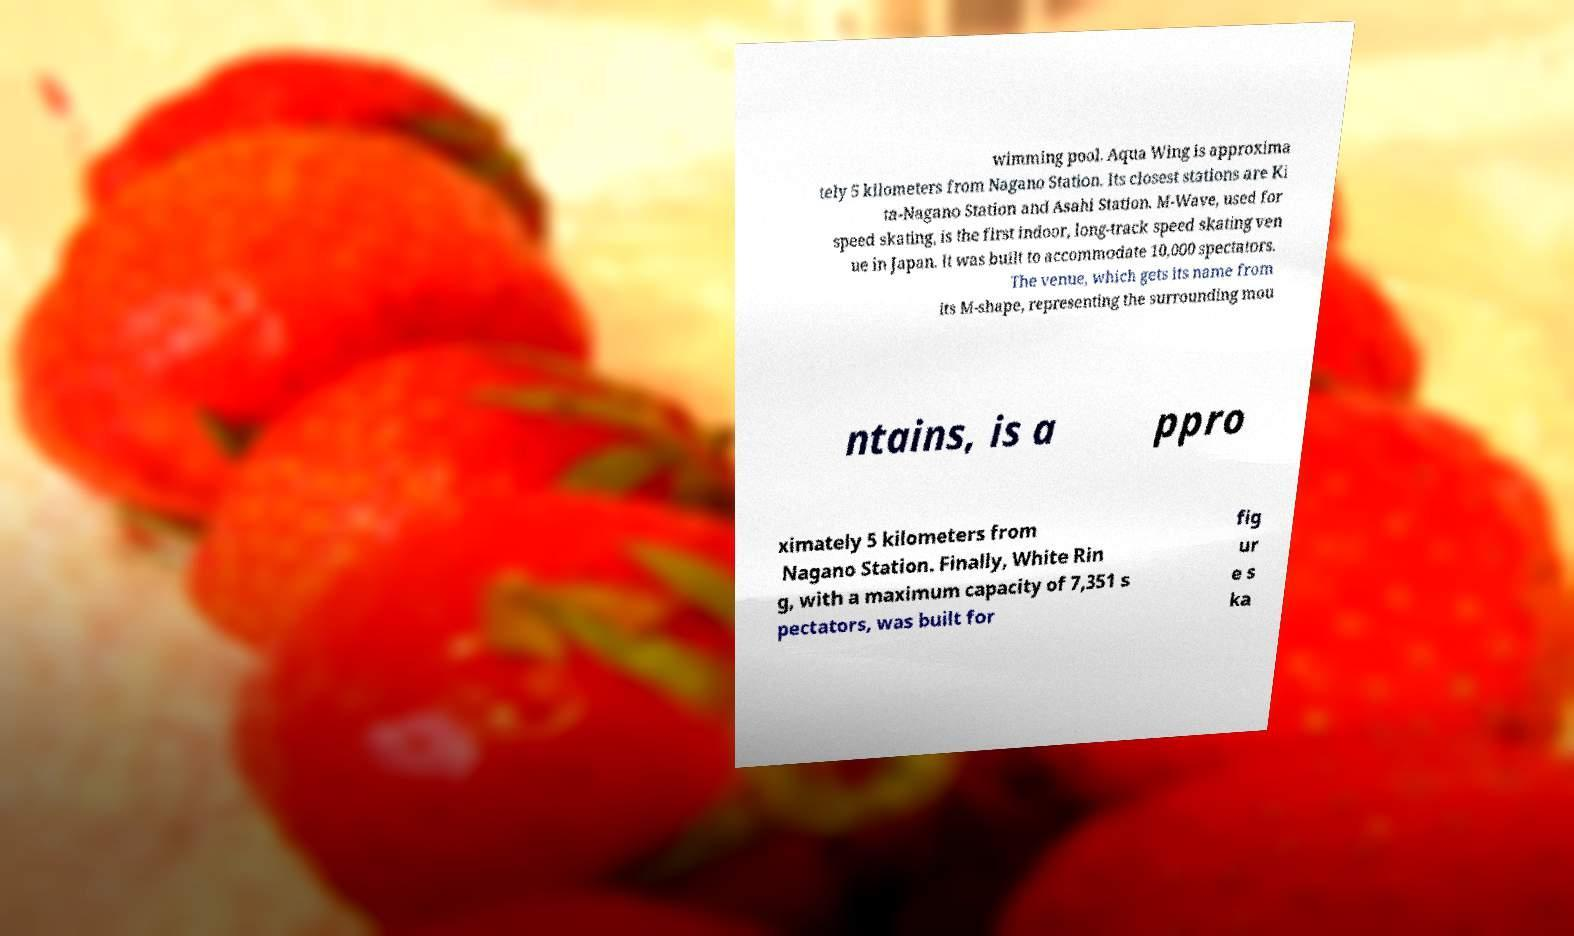Please read and relay the text visible in this image. What does it say? wimming pool. Aqua Wing is approxima tely 5 kilometers from Nagano Station. Its closest stations are Ki ta-Nagano Station and Asahi Station. M-Wave, used for speed skating, is the first indoor, long-track speed skating ven ue in Japan. It was built to accommodate 10,000 spectators. The venue, which gets its name from its M-shape, representing the surrounding mou ntains, is a ppro ximately 5 kilometers from Nagano Station. Finally, White Rin g, with a maximum capacity of 7,351 s pectators, was built for fig ur e s ka 